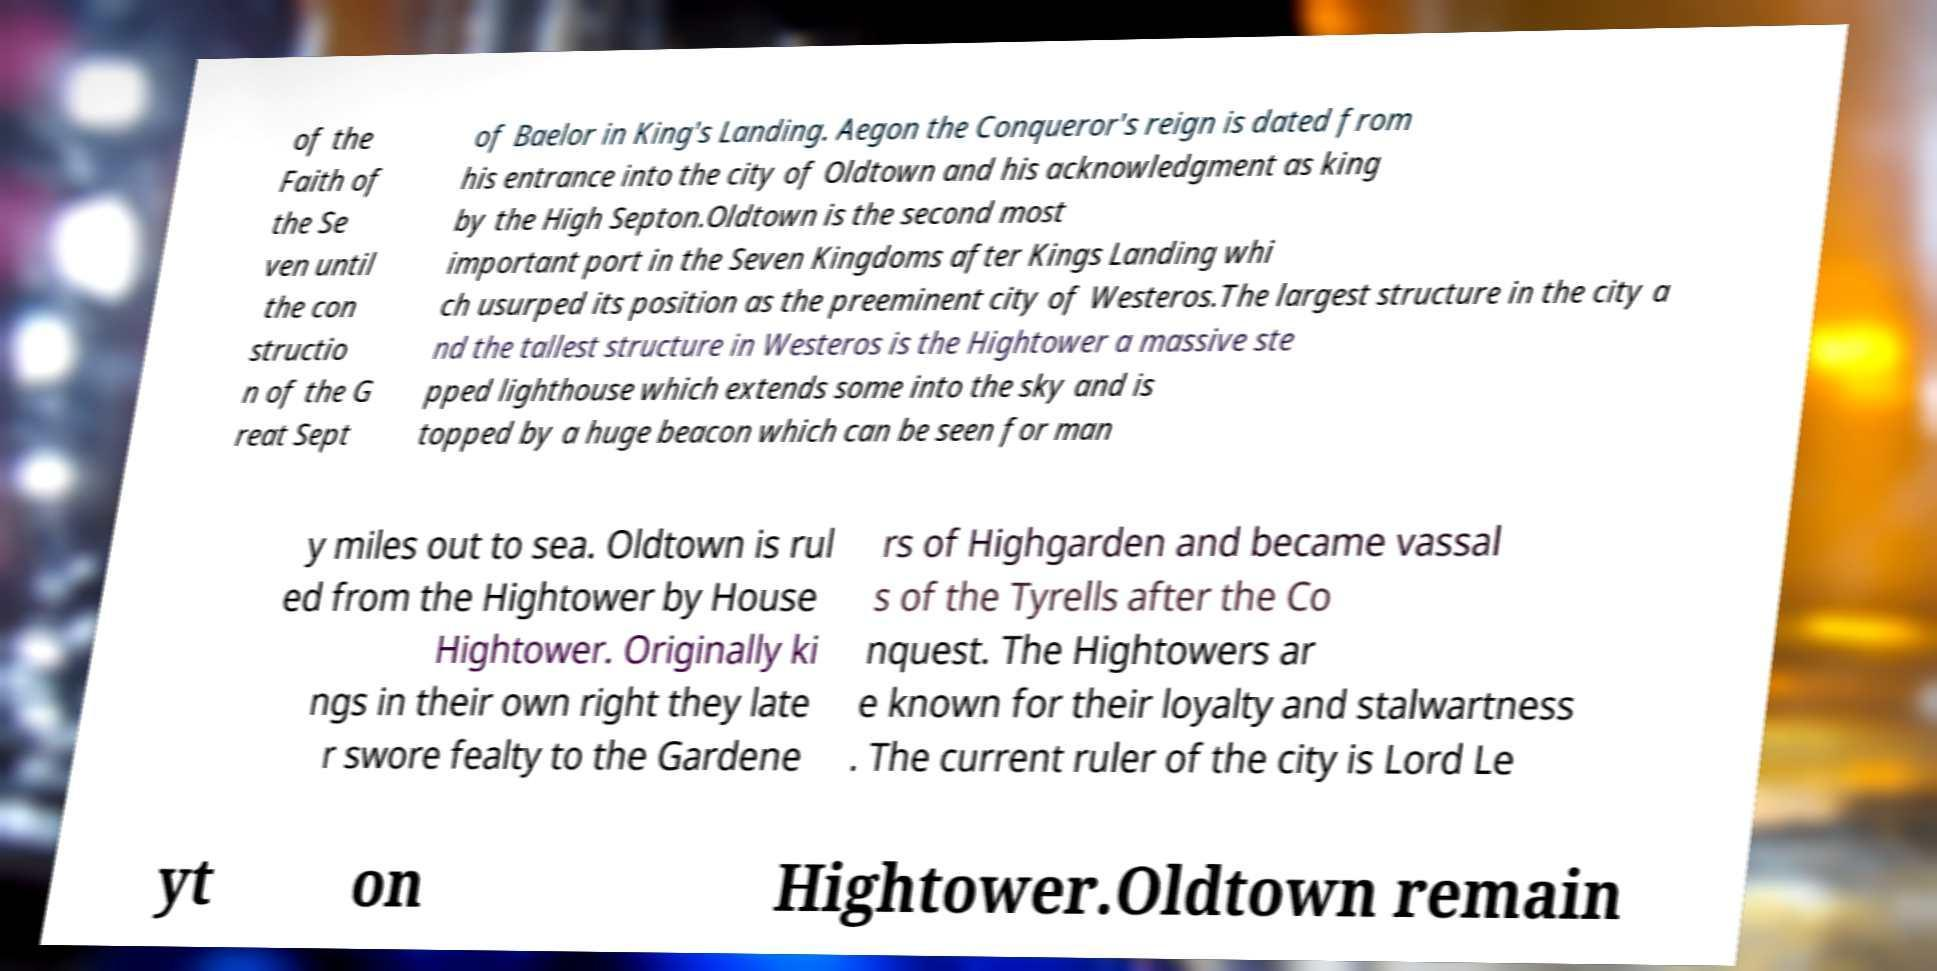Could you assist in decoding the text presented in this image and type it out clearly? of the Faith of the Se ven until the con structio n of the G reat Sept of Baelor in King's Landing. Aegon the Conqueror's reign is dated from his entrance into the city of Oldtown and his acknowledgment as king by the High Septon.Oldtown is the second most important port in the Seven Kingdoms after Kings Landing whi ch usurped its position as the preeminent city of Westeros.The largest structure in the city a nd the tallest structure in Westeros is the Hightower a massive ste pped lighthouse which extends some into the sky and is topped by a huge beacon which can be seen for man y miles out to sea. Oldtown is rul ed from the Hightower by House Hightower. Originally ki ngs in their own right they late r swore fealty to the Gardene rs of Highgarden and became vassal s of the Tyrells after the Co nquest. The Hightowers ar e known for their loyalty and stalwartness . The current ruler of the city is Lord Le yt on Hightower.Oldtown remain 